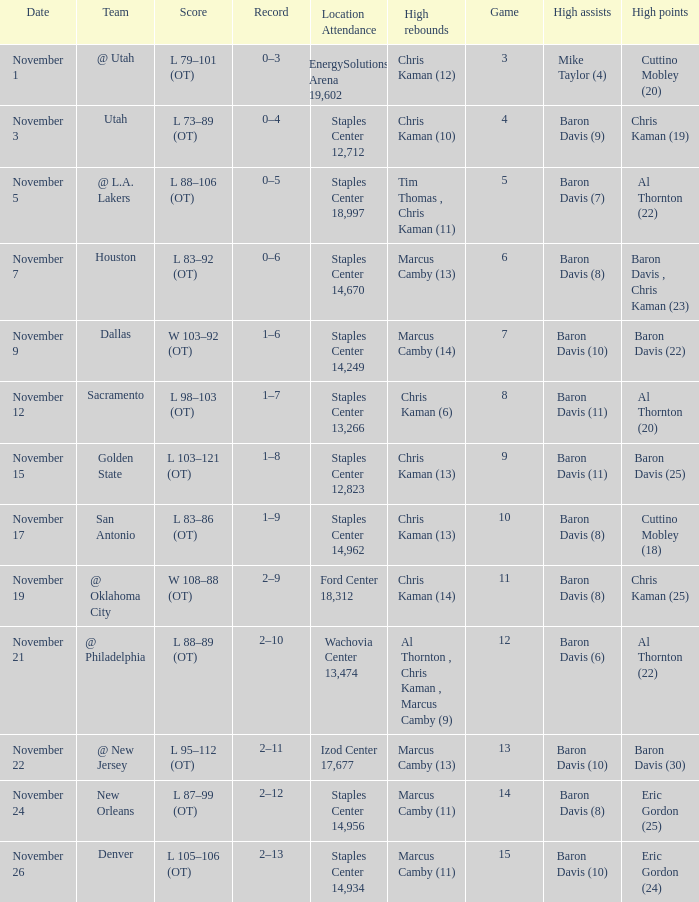Can you give me this table as a dict? {'header': ['Date', 'Team', 'Score', 'Record', 'Location Attendance', 'High rebounds', 'Game', 'High assists', 'High points'], 'rows': [['November 1', '@ Utah', 'L 79–101 (OT)', '0–3', 'EnergySolutions Arena 19,602', 'Chris Kaman (12)', '3', 'Mike Taylor (4)', 'Cuttino Mobley (20)'], ['November 3', 'Utah', 'L 73–89 (OT)', '0–4', 'Staples Center 12,712', 'Chris Kaman (10)', '4', 'Baron Davis (9)', 'Chris Kaman (19)'], ['November 5', '@ L.A. Lakers', 'L 88–106 (OT)', '0–5', 'Staples Center 18,997', 'Tim Thomas , Chris Kaman (11)', '5', 'Baron Davis (7)', 'Al Thornton (22)'], ['November 7', 'Houston', 'L 83–92 (OT)', '0–6', 'Staples Center 14,670', 'Marcus Camby (13)', '6', 'Baron Davis (8)', 'Baron Davis , Chris Kaman (23)'], ['November 9', 'Dallas', 'W 103–92 (OT)', '1–6', 'Staples Center 14,249', 'Marcus Camby (14)', '7', 'Baron Davis (10)', 'Baron Davis (22)'], ['November 12', 'Sacramento', 'L 98–103 (OT)', '1–7', 'Staples Center 13,266', 'Chris Kaman (6)', '8', 'Baron Davis (11)', 'Al Thornton (20)'], ['November 15', 'Golden State', 'L 103–121 (OT)', '1–8', 'Staples Center 12,823', 'Chris Kaman (13)', '9', 'Baron Davis (11)', 'Baron Davis (25)'], ['November 17', 'San Antonio', 'L 83–86 (OT)', '1–9', 'Staples Center 14,962', 'Chris Kaman (13)', '10', 'Baron Davis (8)', 'Cuttino Mobley (18)'], ['November 19', '@ Oklahoma City', 'W 108–88 (OT)', '2–9', 'Ford Center 18,312', 'Chris Kaman (14)', '11', 'Baron Davis (8)', 'Chris Kaman (25)'], ['November 21', '@ Philadelphia', 'L 88–89 (OT)', '2–10', 'Wachovia Center 13,474', 'Al Thornton , Chris Kaman , Marcus Camby (9)', '12', 'Baron Davis (6)', 'Al Thornton (22)'], ['November 22', '@ New Jersey', 'L 95–112 (OT)', '2–11', 'Izod Center 17,677', 'Marcus Camby (13)', '13', 'Baron Davis (10)', 'Baron Davis (30)'], ['November 24', 'New Orleans', 'L 87–99 (OT)', '2–12', 'Staples Center 14,956', 'Marcus Camby (11)', '14', 'Baron Davis (8)', 'Eric Gordon (25)'], ['November 26', 'Denver', 'L 105–106 (OT)', '2–13', 'Staples Center 14,934', 'Marcus Camby (11)', '15', 'Baron Davis (10)', 'Eric Gordon (24)']]} Name the high assists for  l 98–103 (ot) Baron Davis (11). 